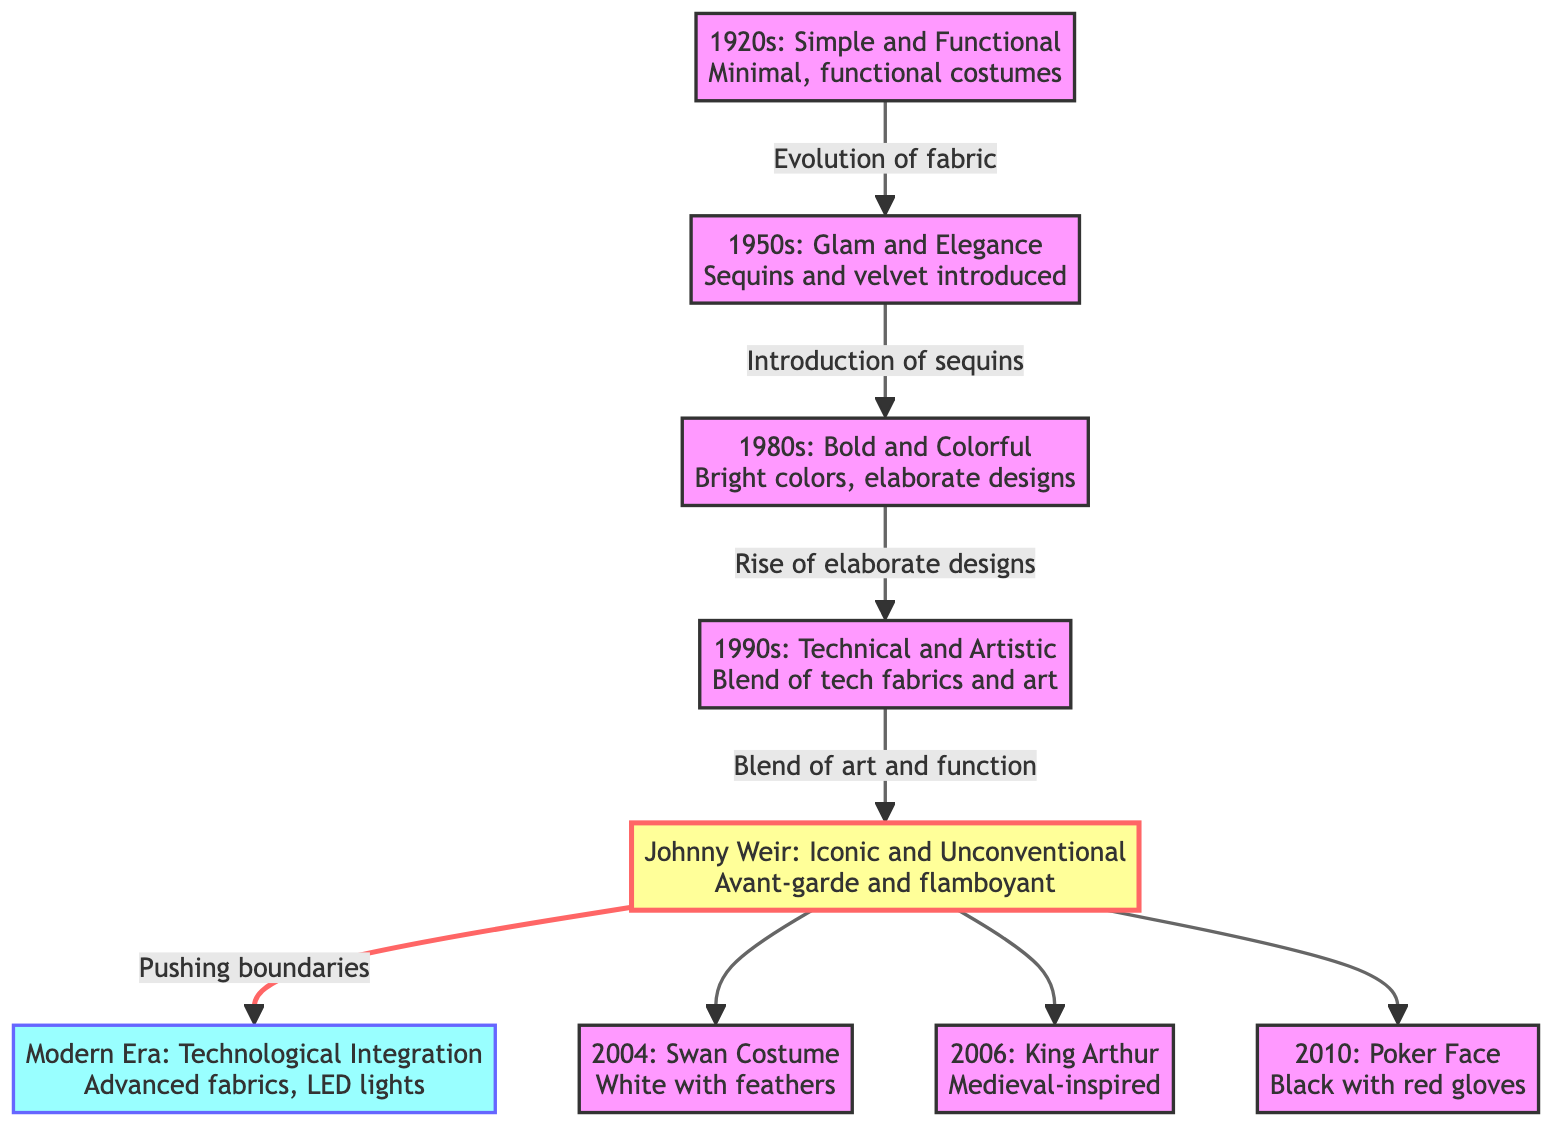What decade marks the introduction of sequins in figure skating costumes? According to the diagram, the link from the 1950s to the 1980s indicates that sequins were introduced during the 1950s.
Answer: 1950s How many specific outfits of Johnny Weir are highlighted in the diagram? The diagram shows three specific outfits from Johnny Weir, which are the Swan Costume (2004), King Arthur (2006), and Poker Face (2010).
Answer: 3 What costume design signifies Johnny Weir's approach to figure skating outfits? The diagram describes Johnny Weir's outfits as "Avant-garde and flamboyant," which is a key term indicating his unique style.
Answer: Avant-garde and flamboyant Which decade transitioned into the modern era of figure skating costumes according to the diagram? The relationship links Johnny Weir's contributions, which push boundaries, into the Modern Era as indicated at the end of the flow. This indicates that Johnny Weir's style is a precursor to the modern era.
Answer: Modern Era What is the relationship between the 1990s and Johnny Weir's costume design? The diagram illustrates a prominent connection marked by the phrase "Blend of art and function," indicating that the costumes from the 1990s transitioned into Johnny Weir's unique approach known for its unconventionality.
Answer: Blend of art and function What style is associated with figure skating costumes in the 1980s? The diagram characterizes this decade with the phrase "Bold and Colorful," signifying the dominant design style of that period.
Answer: Bold and Colorful Which decade is characterized by simple and functional costumes? Directly from the diagram, the initial node says "1920s: Simple and Functional," identifying the era characterized by minimalistic designs.
Answer: 1920s What specific costume did Johnny Weir wear in 2004? The diagram specifies that Johnny Weir wore the "Swan Costume" in 2004, describing it as "White with feathers."
Answer: Swan Costume 